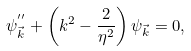Convert formula to latex. <formula><loc_0><loc_0><loc_500><loc_500>\psi _ { \vec { k } } ^ { ^ { \prime \prime } } + \left ( k ^ { 2 } - \frac { 2 } { \eta ^ { 2 } } \right ) \psi _ { \vec { k } } = 0 ,</formula> 